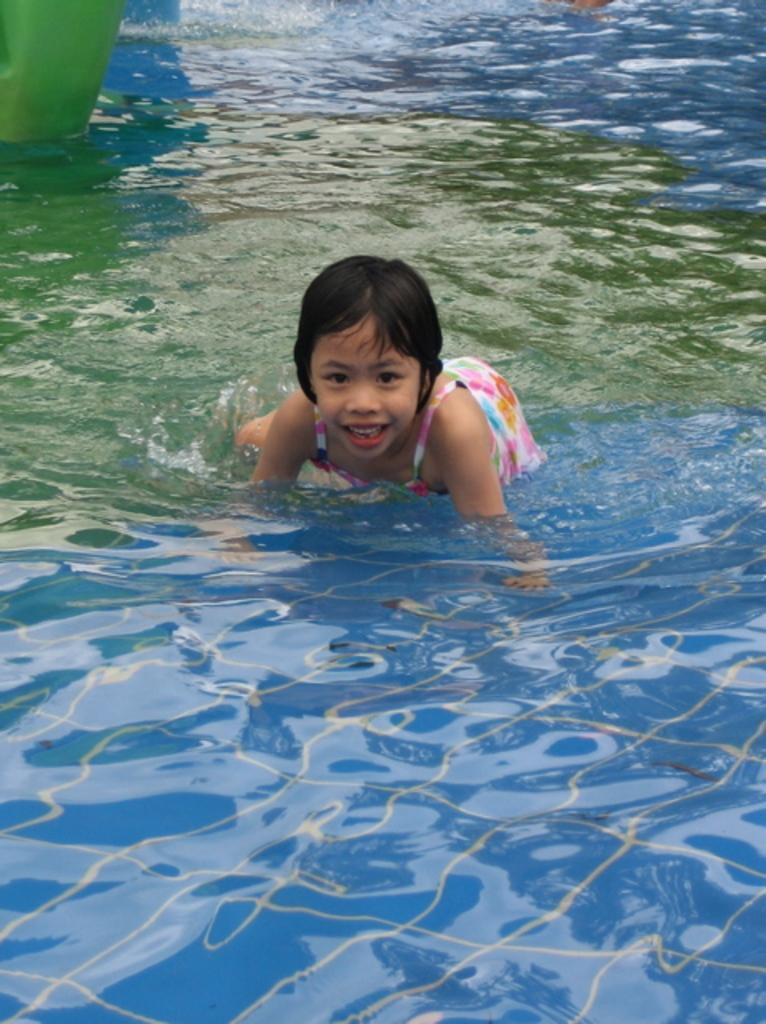Who is the main subject in the image? There is a girl in the image. What is the girl doing in the image? The girl is standing in water. What type of salt is being used to season the girl's leg in the image? There is no salt or any indication of seasoning in the image; the girl is simply standing in water. 